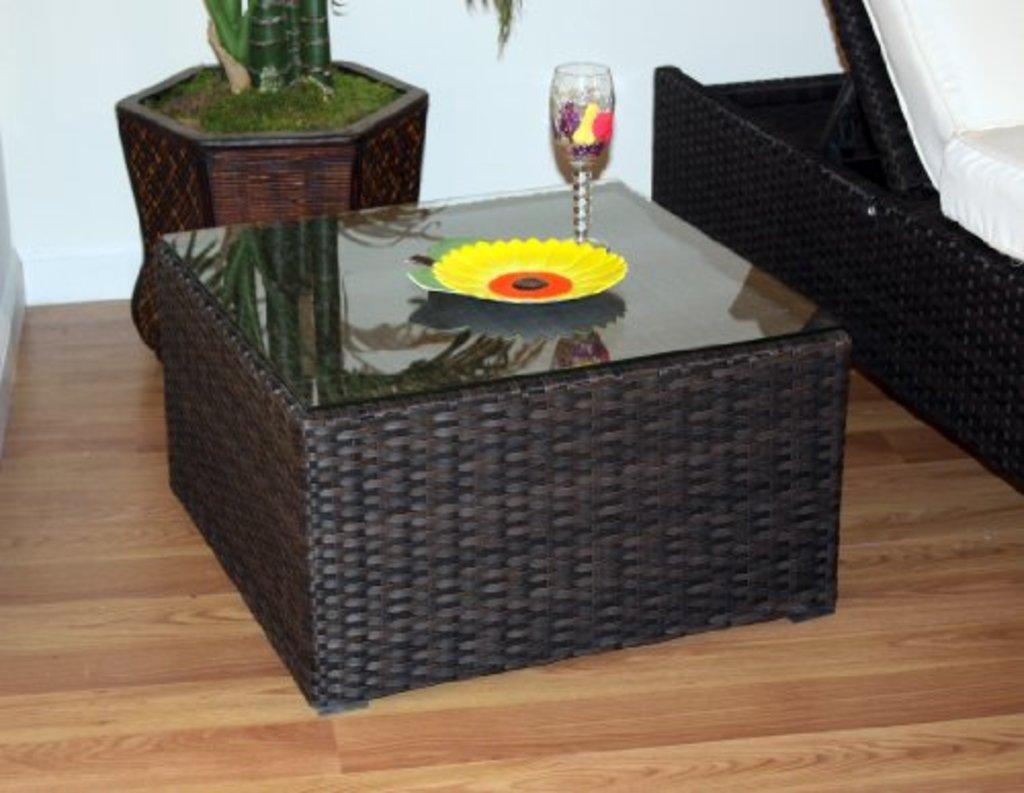Please provide a concise description of this image. In this picture we can see plate and glass on the table, sofa, house plant and floor. In the background of the image we can see wall. 